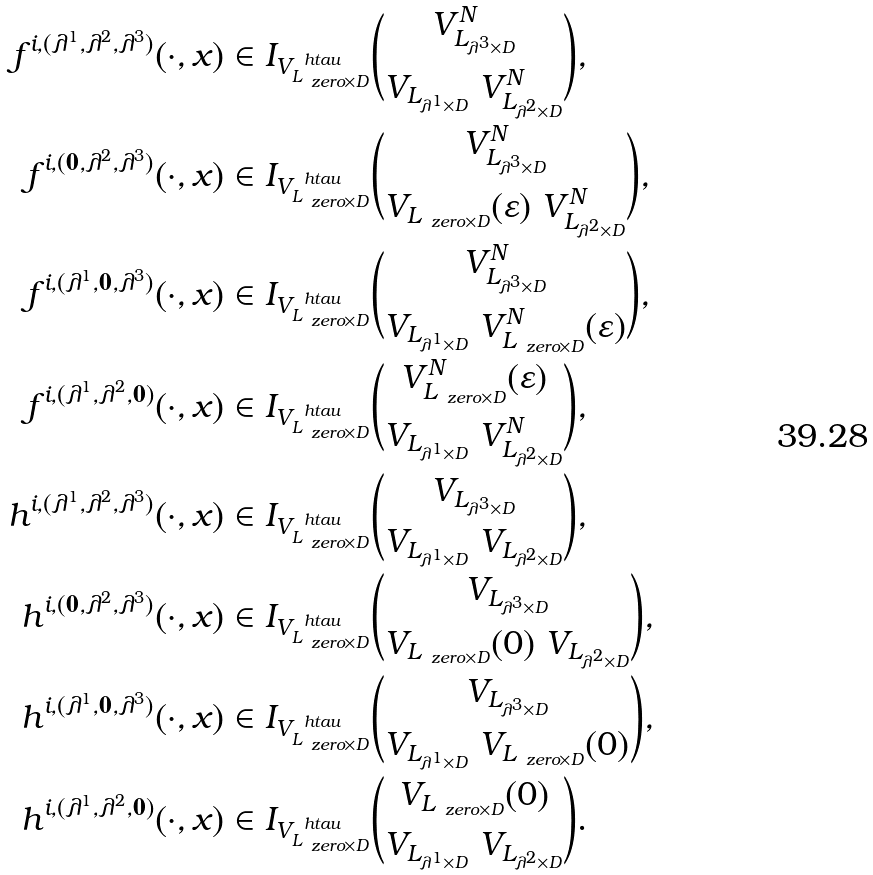<formula> <loc_0><loc_0><loc_500><loc_500>f ^ { i , ( \lambda ^ { 1 } , \lambda ^ { 2 } , \lambda ^ { 3 } ) } ( \cdot , x ) & \in I _ { V _ { L _ { \ z e r o \times D } } ^ { \ h t a u } } \binom { V ^ { N } _ { L _ { \lambda ^ { 3 } \times D } } } { V _ { L _ { \lambda ^ { 1 } \times D } } \ V ^ { N } _ { L _ { \lambda ^ { 2 } \times D } } } , \\ f ^ { i , ( { \mathbf 0 } , \lambda ^ { 2 } , \lambda ^ { 3 } ) } ( \cdot , x ) & \in I _ { V _ { L _ { \ z e r o \times D } } ^ { \ h t a u } } \binom { V ^ { N } _ { L _ { \lambda ^ { 3 } \times D } } } { V _ { L _ { \ z e r o \times D } } ( \varepsilon ) \ V ^ { N } _ { L _ { \lambda ^ { 2 } \times D } } } , \\ f ^ { i , ( \lambda ^ { 1 } , { \mathbf 0 } , \lambda ^ { 3 } ) } ( \cdot , x ) & \in I _ { V _ { L _ { \ z e r o \times D } } ^ { \ h t a u } } \binom { V ^ { N } _ { L _ { \lambda ^ { 3 } \times D } } } { V _ { L _ { \lambda ^ { 1 } \times D } } \ V ^ { N } _ { L _ { \ z e r o \times D } } ( \varepsilon ) } , \\ f ^ { i , ( \lambda ^ { 1 } , \lambda ^ { 2 } , { \mathbf 0 } ) } ( \cdot , x ) & \in I _ { V _ { L _ { \ z e r o \times D } } ^ { \ h t a u } } \binom { V ^ { N } _ { L _ { \ z e r o \times D } } ( \varepsilon ) } { V _ { L _ { \lambda ^ { 1 } \times D } } \ V ^ { N } _ { L _ { \lambda ^ { 2 } \times D } } } , \\ h ^ { i , ( \lambda ^ { 1 } , \lambda ^ { 2 } , \lambda ^ { 3 } ) } ( \cdot , x ) & \in I _ { V _ { L _ { \ z e r o \times D } } ^ { \ h t a u } } \binom { V _ { L _ { \lambda ^ { 3 } \times D } } } { V _ { L _ { \lambda ^ { 1 } \times D } } \ V _ { L _ { \lambda ^ { 2 } \times D } } } , \\ h ^ { i , ( { \mathbf 0 } , \lambda ^ { 2 } , \lambda ^ { 3 } ) } ( \cdot , x ) & \in I _ { V _ { L _ { \ z e r o \times D } } ^ { \ h t a u } } \binom { V _ { L _ { \lambda ^ { 3 } \times D } } } { V _ { L _ { \ z e r o \times D } } ( 0 ) \ V _ { L _ { \lambda ^ { 2 } \times D } } } , \\ h ^ { i , ( \lambda ^ { 1 } , { \mathbf 0 } , \lambda ^ { 3 } ) } ( \cdot , x ) & \in I _ { V _ { L _ { \ z e r o \times D } } ^ { \ h t a u } } \binom { V _ { L _ { \lambda ^ { 3 } \times D } } } { V _ { L _ { \lambda ^ { 1 } \times D } } \ V _ { L _ { \ z e r o \times D } } ( 0 ) } , \\ h ^ { i , ( \lambda ^ { 1 } , \lambda ^ { 2 } , { \mathbf 0 } ) } ( \cdot , x ) & \in I _ { V _ { L _ { \ z e r o \times D } } ^ { \ h t a u } } \binom { V _ { L _ { \ z e r o \times D } } ( 0 ) } { V _ { L _ { \lambda ^ { 1 } \times D } } \ V _ { L _ { \lambda ^ { 2 } \times D } } } .</formula> 